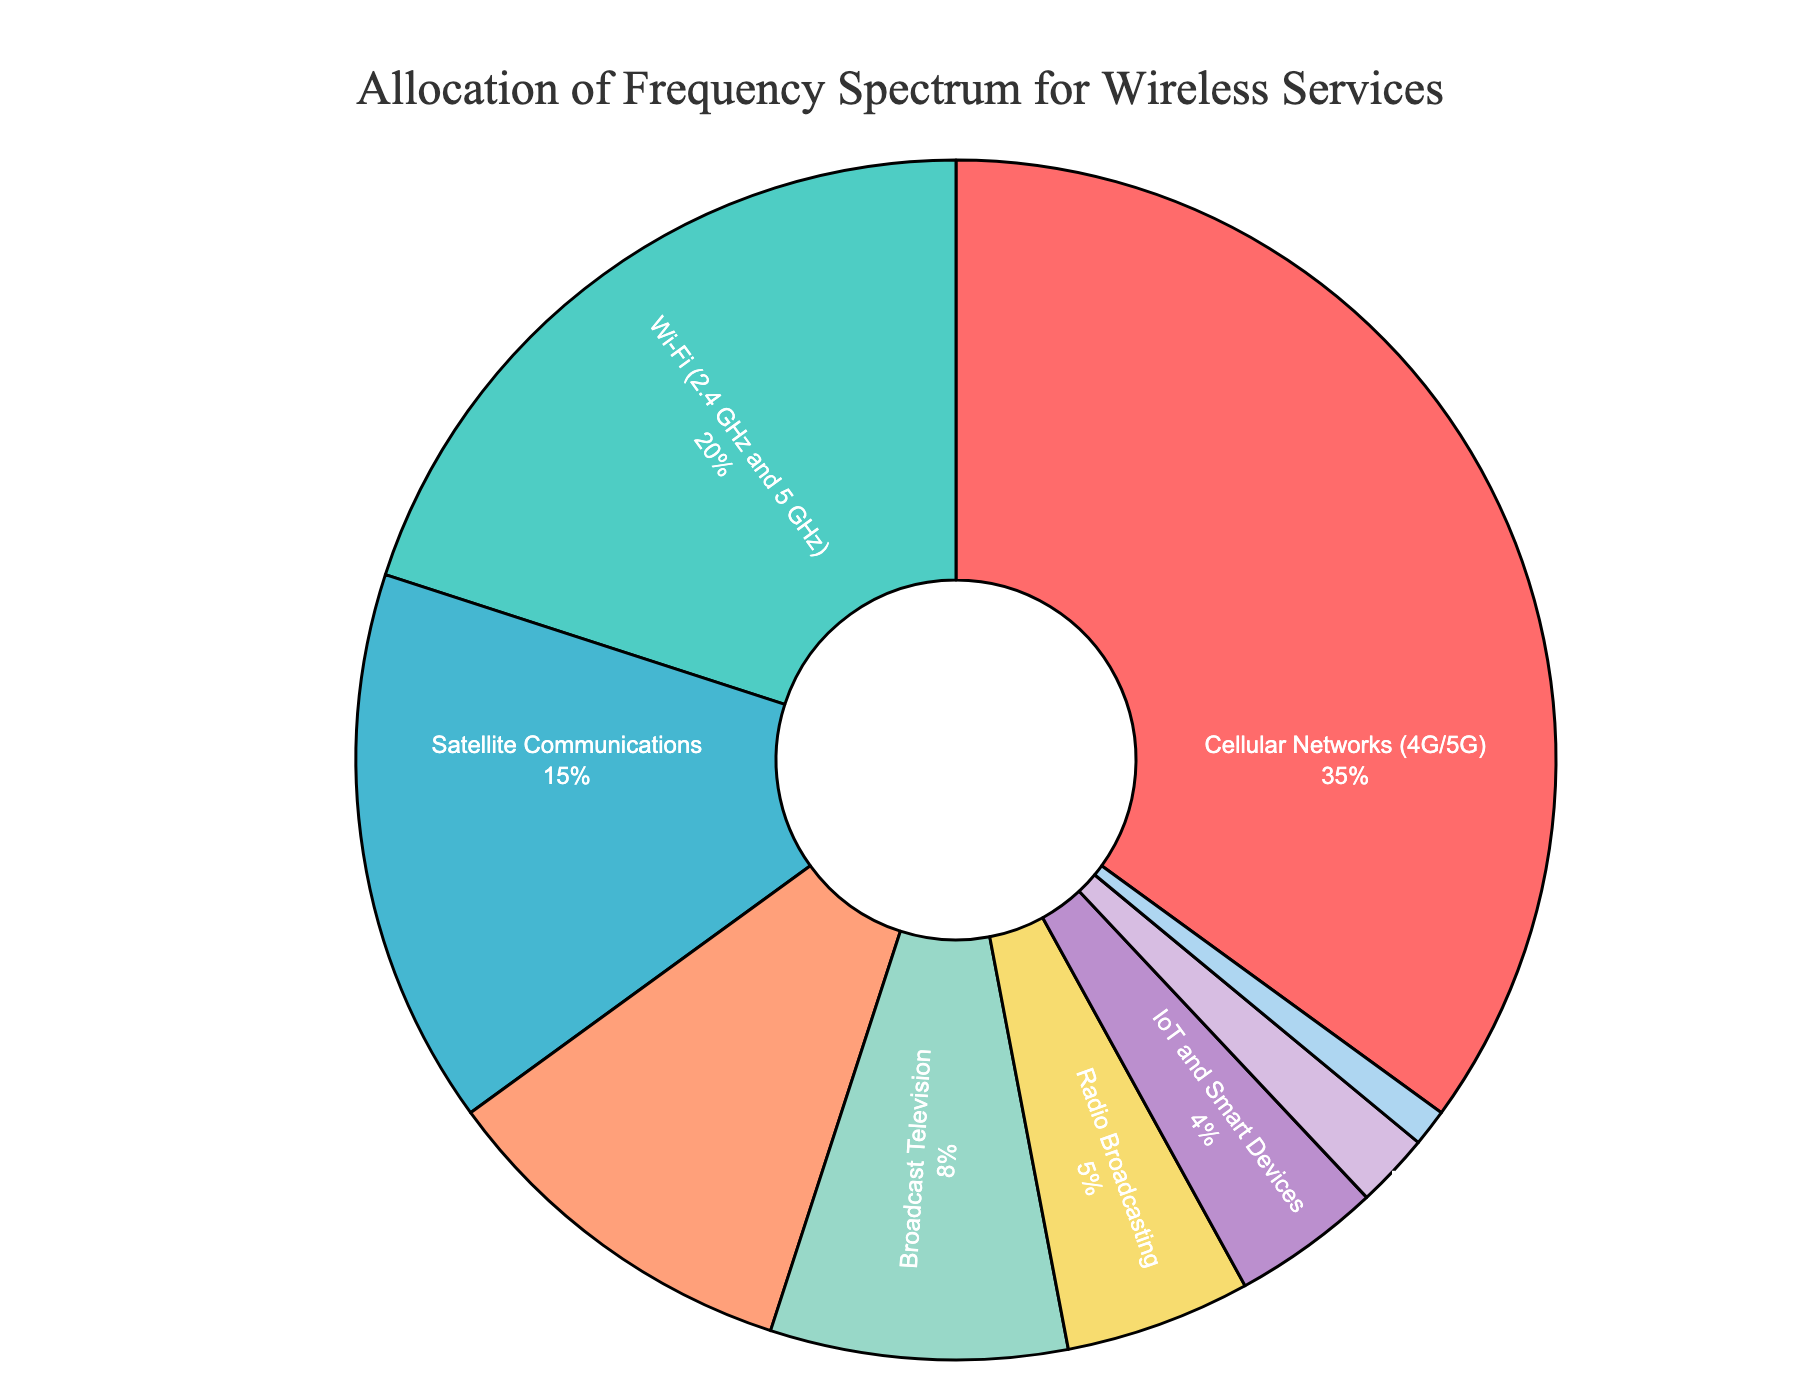Which wireless service uses the largest portion of the frequency spectrum? According to the pie chart, the largest portion of the frequency spectrum is allocated to Cellular Networks (4G/5G) with a percentage value that is visually the biggest slice.
Answer: Cellular Networks (4G/5G) What is the combined percentage of frequency spectrum allocated to Wi-Fi and IoT and Smart Devices? From the pie chart, Wi-Fi is allocated 20% and IoT and Smart Devices are allocated 4%. Adding these together results in 20% + 4% = 24%.
Answer: 24% How much greater is the frequency spectrum allocation for Cellular Networks (4G/5G) compared to Satellite Communications? Cellular Networks (4G/5G) have an allocation of 35%, while Satellite Communications have 15%. The difference is calculated as 35% - 15% = 20%.
Answer: 20% Which service uses a smaller portion of the frequency spectrum, Broadcast Television or Public Safety and Emergency Services? Broadcast Television has an allocation of 8%, while Public Safety and Emergency Services have 10%. Since 8% is smaller than 10%, Broadcast Television uses a smaller portion.
Answer: Broadcast Television What percentage of the frequency spectrum is allocated to non-cellular services (exclusive of Cellular Networks (4G/5G))? Subtract the percentage of Cellular Networks (35%) from 100%. That is 100% - 35% = 65%.
Answer: 65% Which colored segment in the pie chart represents the frequency spectrum allocation for Satellite Communications? According to the chart's description, Satellite Communications is represented by one of the colors used in the slices. By identifying the color that corresponds to 15%, we find it is the light blue segment.
Answer: Light Blue What is the total percentage for services allocated less than 10% individually? The services with less than 10% are Broadcast Television (8%), Radio Broadcasting (5%), IoT and Smart Devices (4%), GPS and Navigation (2%), and Amateur Radio (1%). Summing these gives 8% + 5% + 4% + 2% + 1% = 20%.
Answer: 20% Is the allocation for Public Safety and Emergency Services more or less than twice the allocation for GPS and Navigation? Twice the percentage of GPS and Navigation (2%) is 2% * 2 = 4%. The allocation for Public Safety and Emergency Services is 10%, which is more than 4%.
Answer: More Rank the following services by their percentage allocation from highest to lowest: GPS and Navigation, Radio Broadcasting, IoT and Smart Devices, Amateur Radio. By their percentage allocations listed on the pie chart: Radio Broadcasting (5%), IoT and Smart Devices (4%), GPS and Navigation (2%), Amateur Radio (1%).
Answer: Radio Broadcasting, IoT and Smart Devices, GPS and Navigation, Amateur Radio 